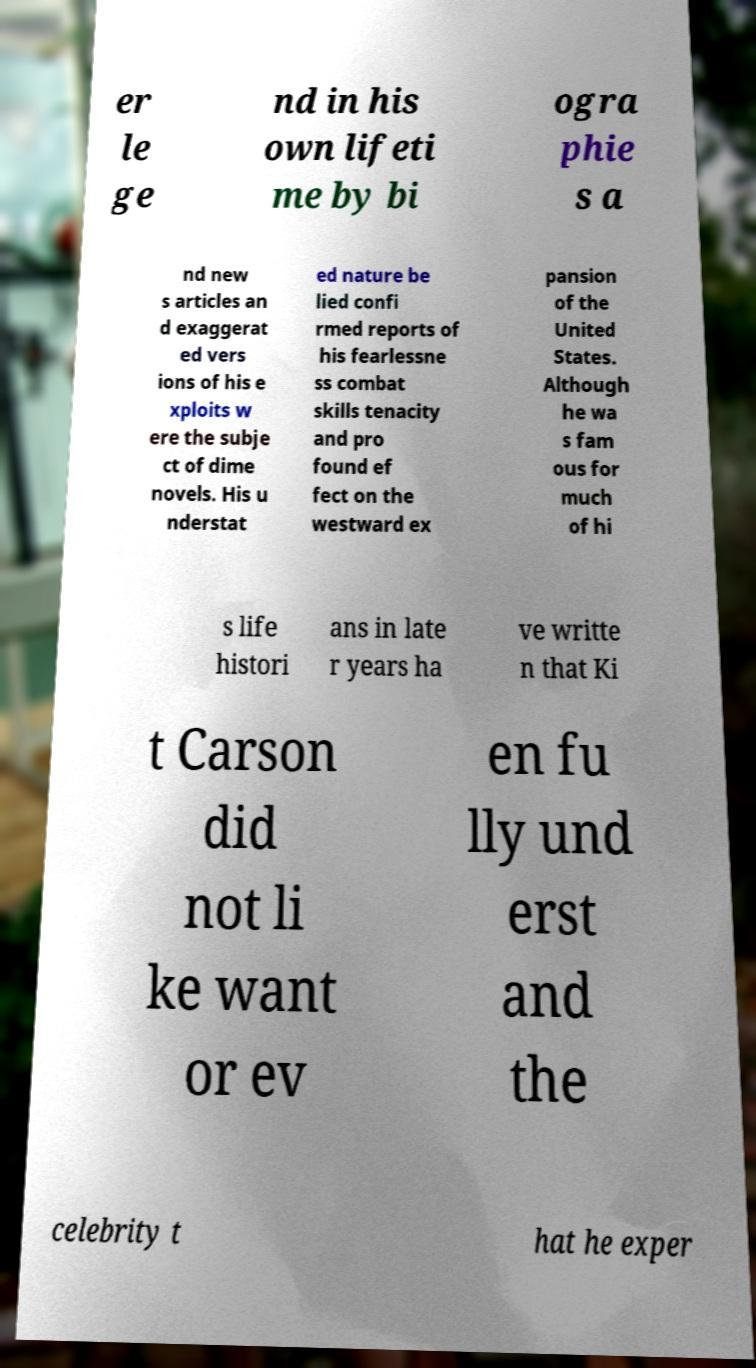There's text embedded in this image that I need extracted. Can you transcribe it verbatim? er le ge nd in his own lifeti me by bi ogra phie s a nd new s articles an d exaggerat ed vers ions of his e xploits w ere the subje ct of dime novels. His u nderstat ed nature be lied confi rmed reports of his fearlessne ss combat skills tenacity and pro found ef fect on the westward ex pansion of the United States. Although he wa s fam ous for much of hi s life histori ans in late r years ha ve writte n that Ki t Carson did not li ke want or ev en fu lly und erst and the celebrity t hat he exper 